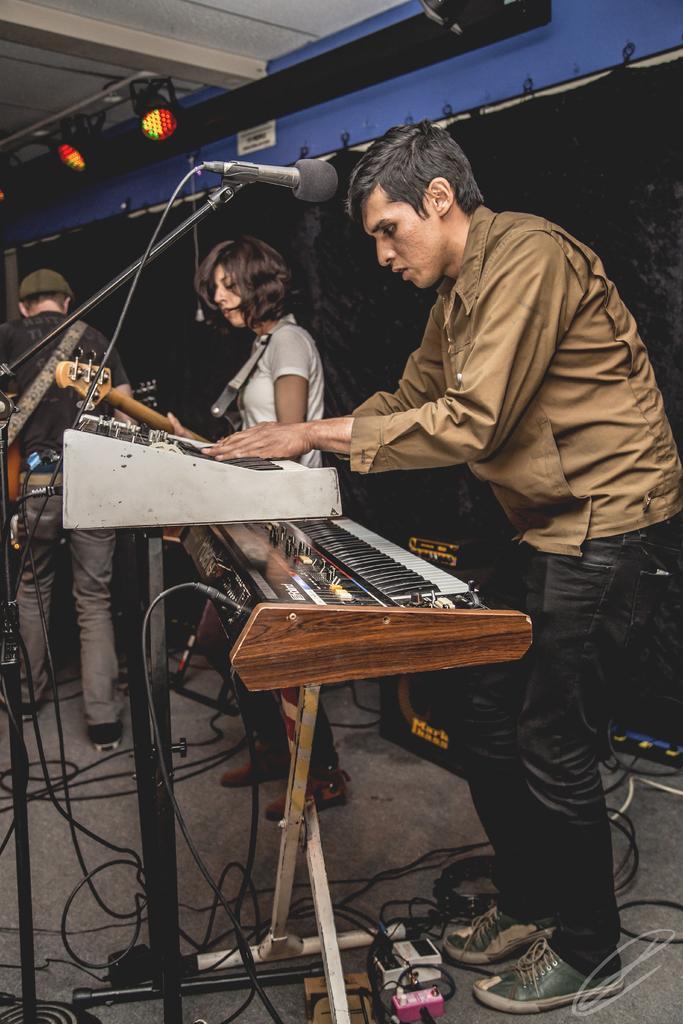Could you give a brief overview of what you see in this image? In this image, I can see the man standing and playing piano. This looks like a mike, which is attached to a mike stand. I can see a woman standing and holding a guitar. On the left side of the image, I can see another person standing. In the background, It looks like a speaker and a curtain hanging. At the top of the image, I think these are the show lights, which are attached to the ceiling. At the bottom of the image, I can see the wires, sockets and few other things on the floor. 